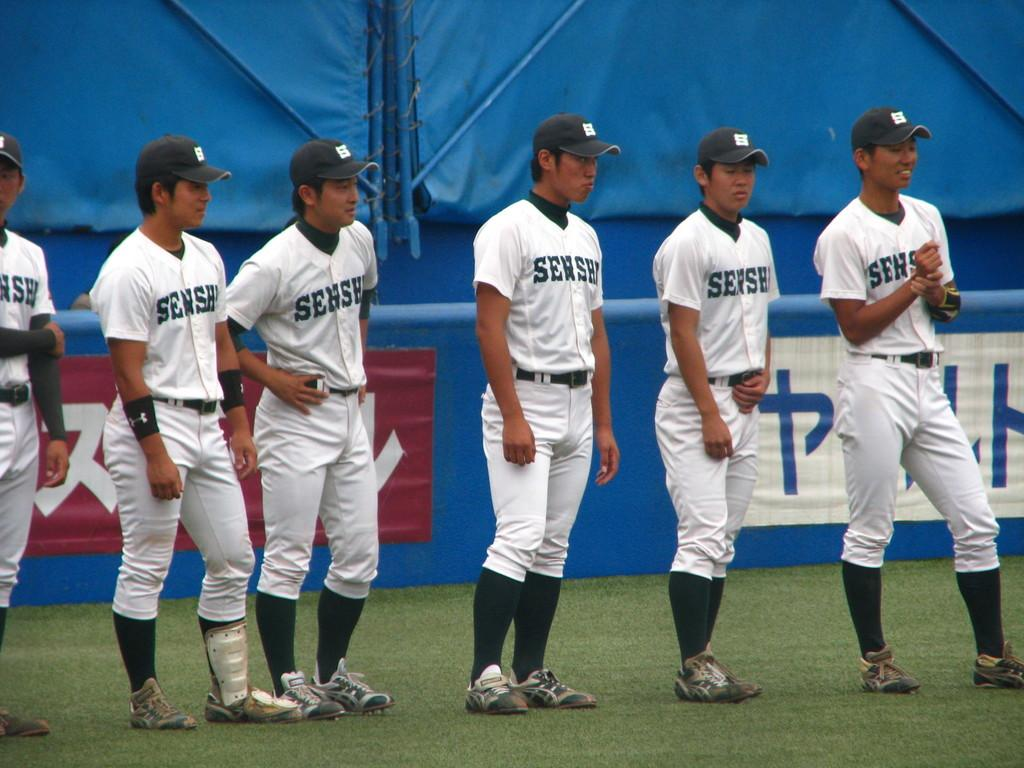<image>
Render a clear and concise summary of the photo. Several players from the Senshi baseball team are lined up in their uniforms. 